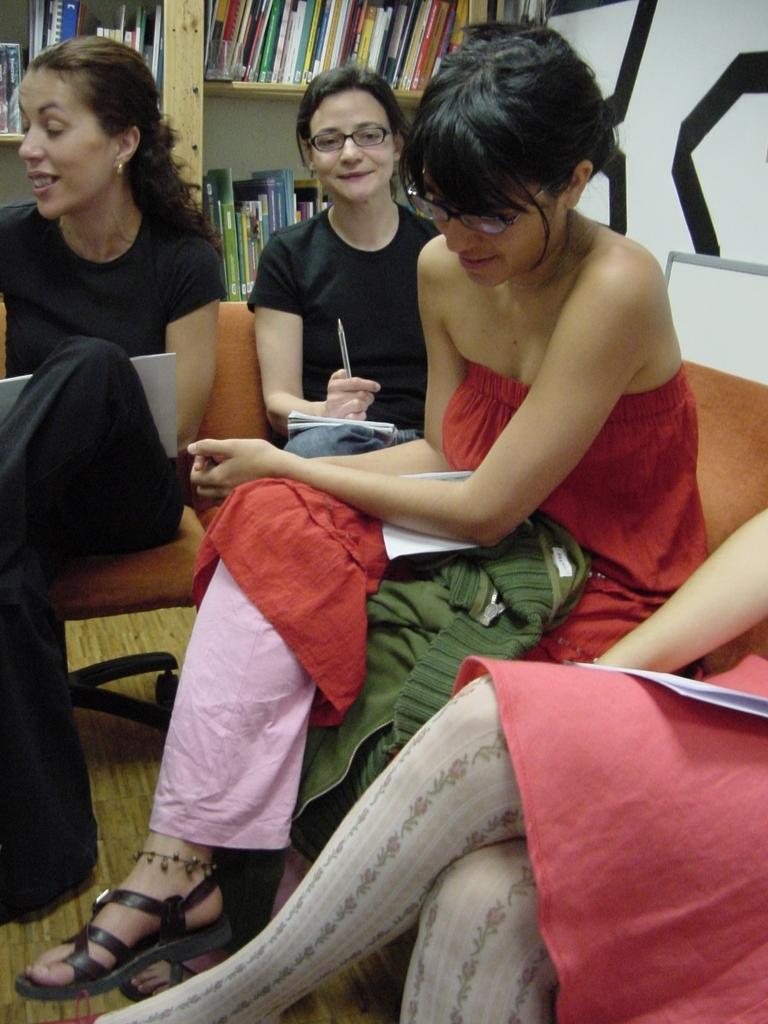In one or two sentences, can you explain what this image depicts? In this image, we can see people are sitting on the chairs. Few people are smiling. Here a woman is holding a pen. At the bottom, we can see wooden floor. Background we can see wooden racks. So many books are placed on it. On the right side top corner, we can see design on the wall. 